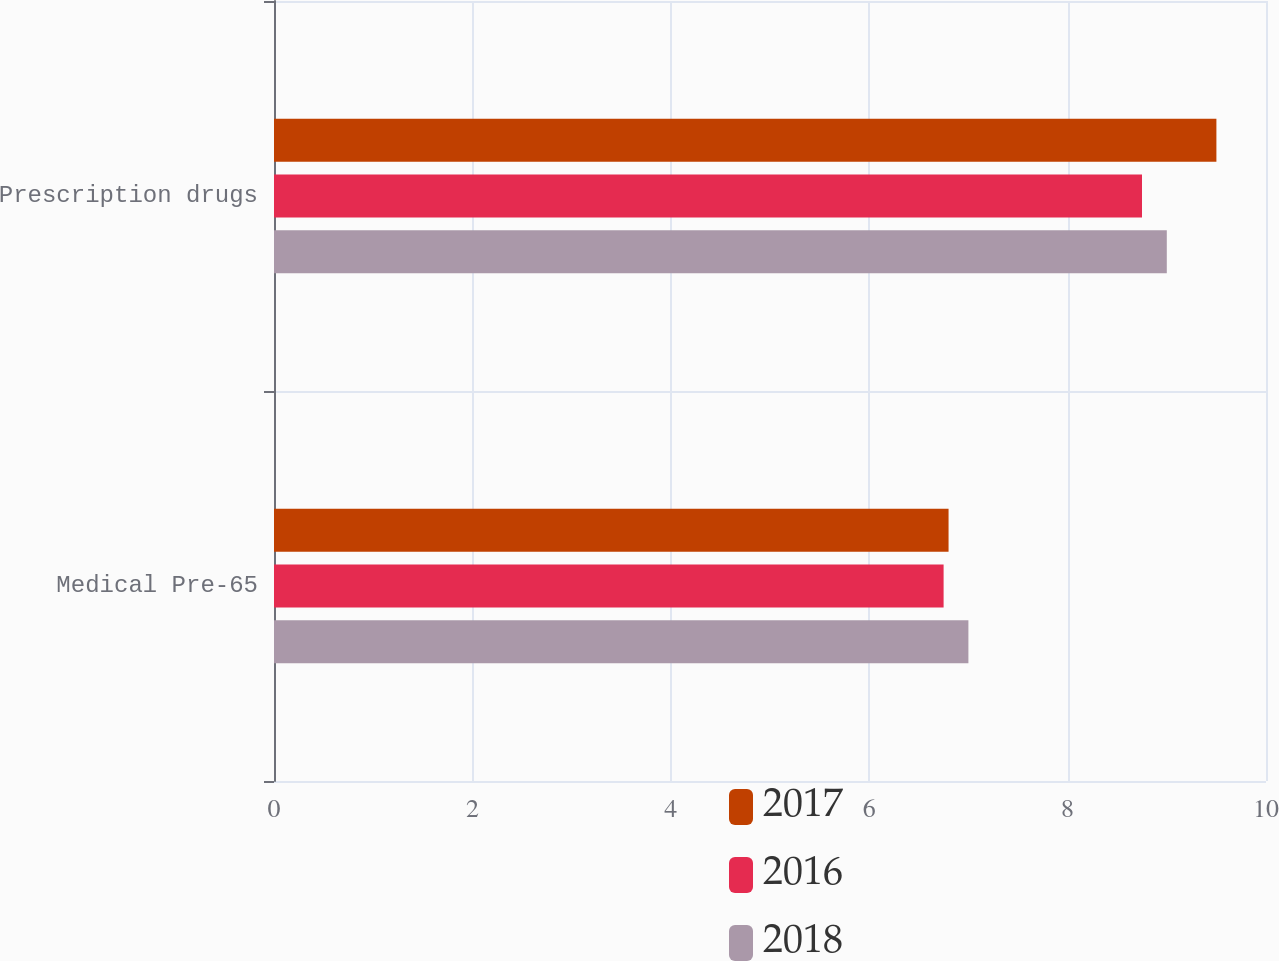Convert chart. <chart><loc_0><loc_0><loc_500><loc_500><stacked_bar_chart><ecel><fcel>Medical Pre-65<fcel>Prescription drugs<nl><fcel>2017<fcel>6.8<fcel>9.5<nl><fcel>2016<fcel>6.75<fcel>8.75<nl><fcel>2018<fcel>7<fcel>9<nl></chart> 